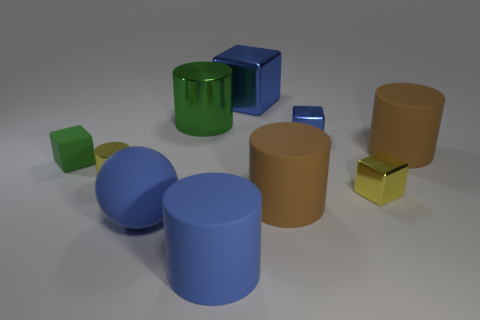Subtract all green cylinders. How many cylinders are left? 4 Subtract all small yellow cylinders. How many cylinders are left? 4 Subtract all red cylinders. Subtract all purple balls. How many cylinders are left? 5 Subtract all spheres. How many objects are left? 9 Subtract all small rubber cubes. Subtract all small cyan metallic blocks. How many objects are left? 9 Add 8 small rubber objects. How many small rubber objects are left? 9 Add 3 purple rubber balls. How many purple rubber balls exist? 3 Subtract 0 yellow balls. How many objects are left? 10 